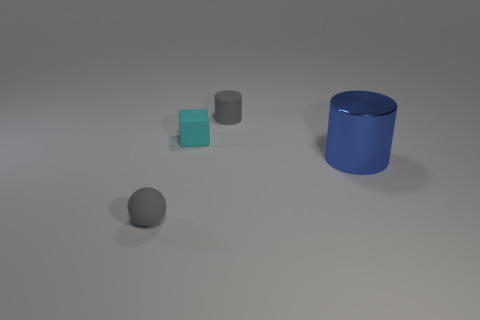Add 4 gray matte objects. How many objects exist? 8 Subtract all cubes. How many objects are left? 3 Subtract all purple cylinders. How many red blocks are left? 0 Subtract all tiny red cylinders. Subtract all small cylinders. How many objects are left? 3 Add 2 big objects. How many big objects are left? 3 Add 4 big purple matte things. How many big purple matte things exist? 4 Subtract all gray cylinders. How many cylinders are left? 1 Subtract 0 green cubes. How many objects are left? 4 Subtract 1 cylinders. How many cylinders are left? 1 Subtract all red balls. Subtract all purple cubes. How many balls are left? 1 